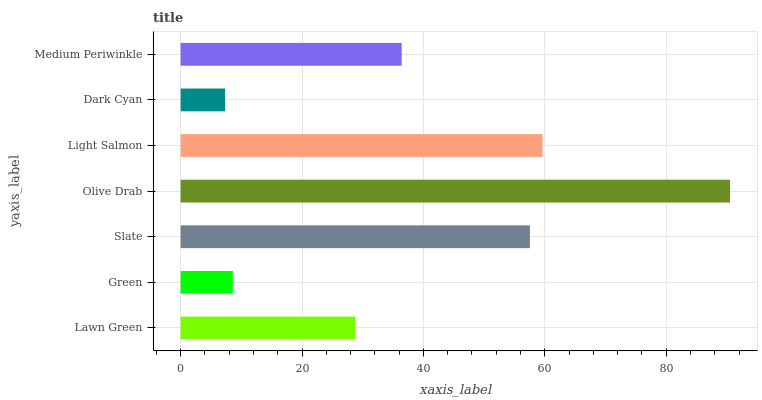Is Dark Cyan the minimum?
Answer yes or no. Yes. Is Olive Drab the maximum?
Answer yes or no. Yes. Is Green the minimum?
Answer yes or no. No. Is Green the maximum?
Answer yes or no. No. Is Lawn Green greater than Green?
Answer yes or no. Yes. Is Green less than Lawn Green?
Answer yes or no. Yes. Is Green greater than Lawn Green?
Answer yes or no. No. Is Lawn Green less than Green?
Answer yes or no. No. Is Medium Periwinkle the high median?
Answer yes or no. Yes. Is Medium Periwinkle the low median?
Answer yes or no. Yes. Is Olive Drab the high median?
Answer yes or no. No. Is Slate the low median?
Answer yes or no. No. 